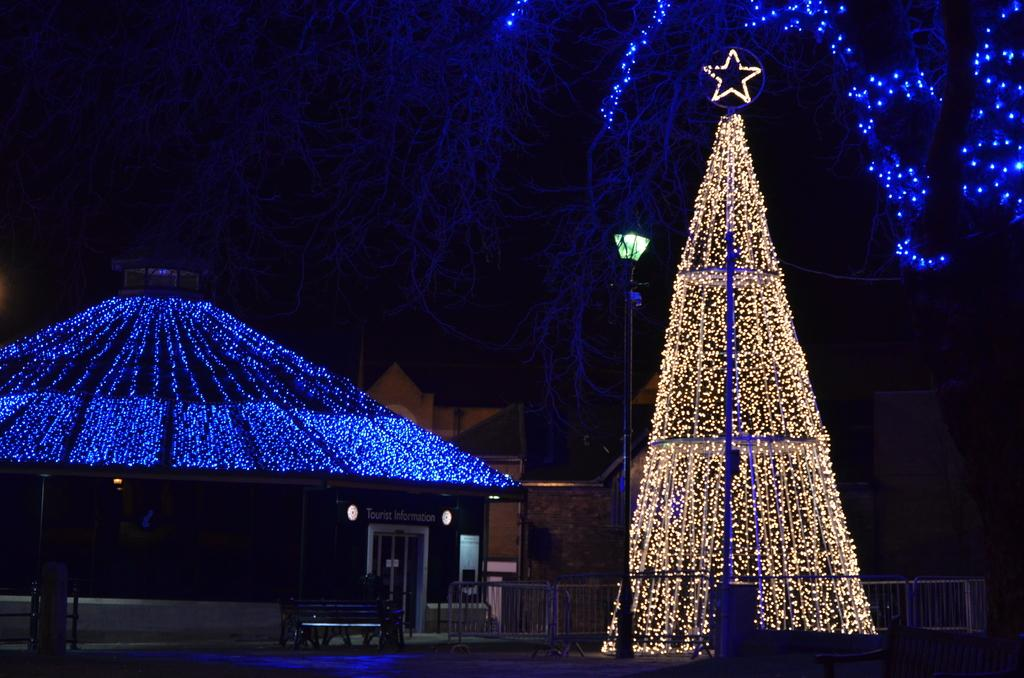What type of lighting is present in the image? There are decorative lights in the image. What structure can be seen in the image? There is a pole in the image. What type of buildings are visible in the image? There are houses in the image. What type of seating is present in the image? There is a bench in the image. What type of signage is present in the image? There are boards in the image. What type of barrier is present in the image? There is a railing in the image. How would you describe the lighting conditions in the image? The background of the image is dark. What type of dinner is being served on the bench in the image? There is no dinner present in the image; it features decorative lights, a pole, houses, a bench, boards, a railing, and a dark background. What type of bushes can be seen growing near the houses in the image? There is no mention of bushes in the image; it only features decorative lights, a pole, houses, a bench, boards, a railing, and a dark background. 